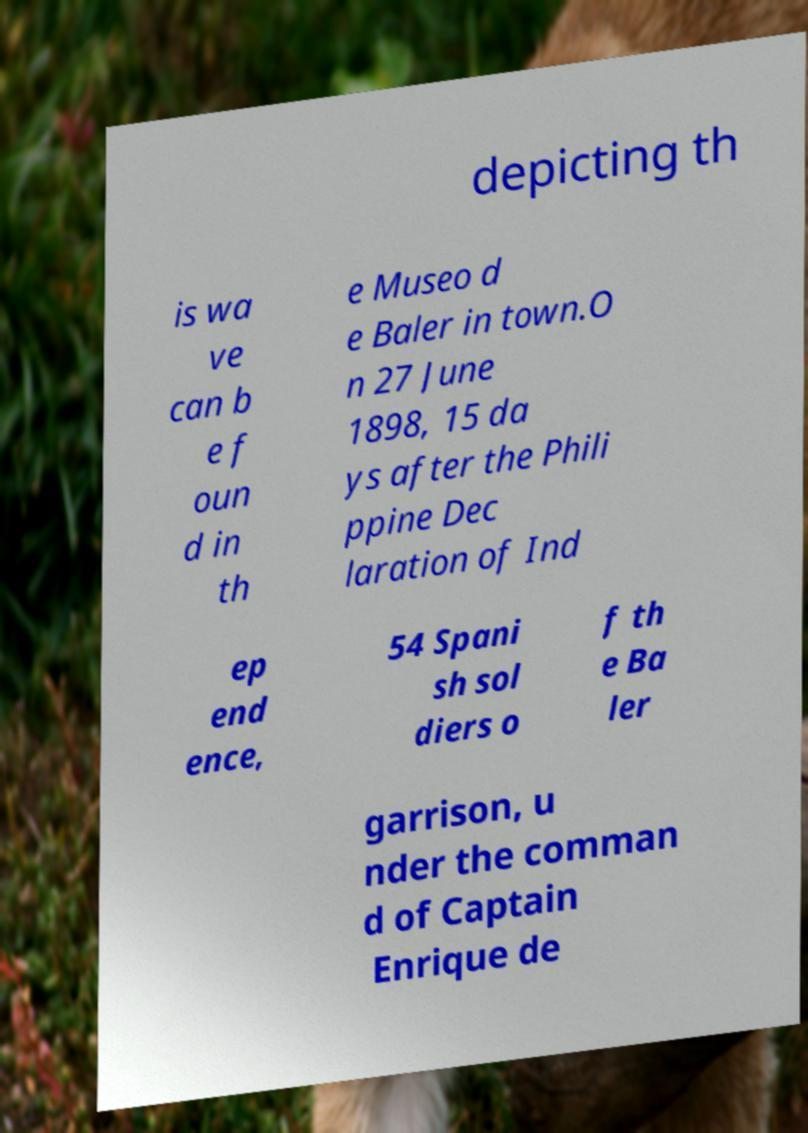Can you read and provide the text displayed in the image?This photo seems to have some interesting text. Can you extract and type it out for me? depicting th is wa ve can b e f oun d in th e Museo d e Baler in town.O n 27 June 1898, 15 da ys after the Phili ppine Dec laration of Ind ep end ence, 54 Spani sh sol diers o f th e Ba ler garrison, u nder the comman d of Captain Enrique de 